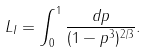<formula> <loc_0><loc_0><loc_500><loc_500>L _ { I } = \int _ { 0 } ^ { 1 } \frac { d p } { ( 1 - p ^ { 3 } ) ^ { 2 / 3 } } .</formula> 